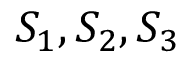Convert formula to latex. <formula><loc_0><loc_0><loc_500><loc_500>S _ { 1 } , S _ { 2 } , S _ { 3 }</formula> 